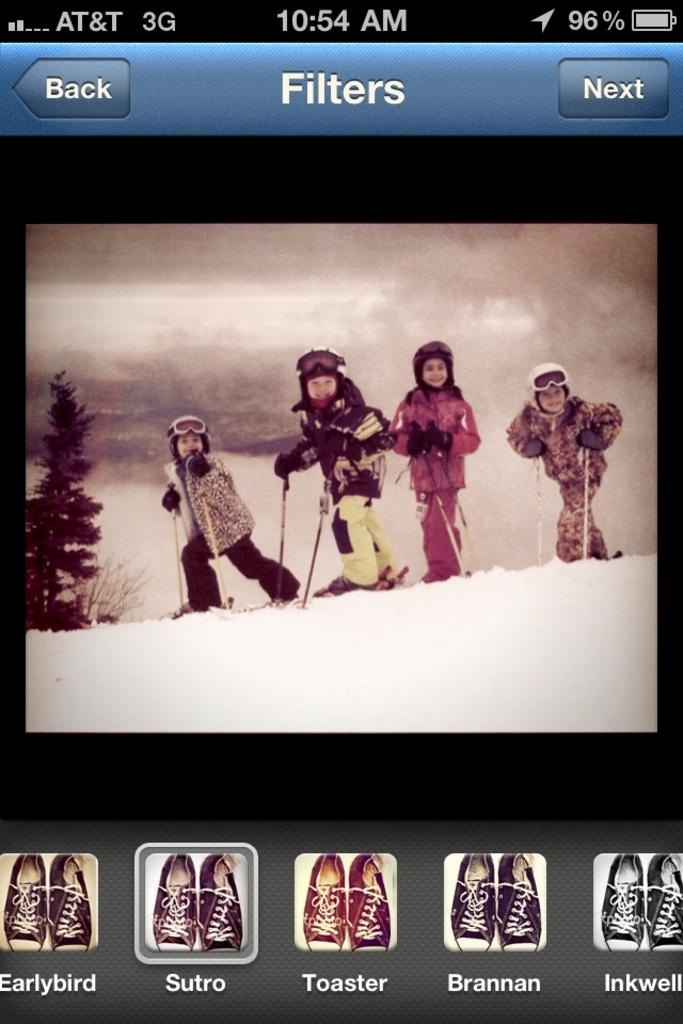What type of image is shown in the screenshot? The screenshot shows a picture being edited with filters. What device was used to capture the screenshot? The screenshot was taken on a mobile phone. What type of cave is visible in the background of the edited picture? There is no cave visible in the image, as the screenshot shows a picture being edited with filters, and no background is shown. 